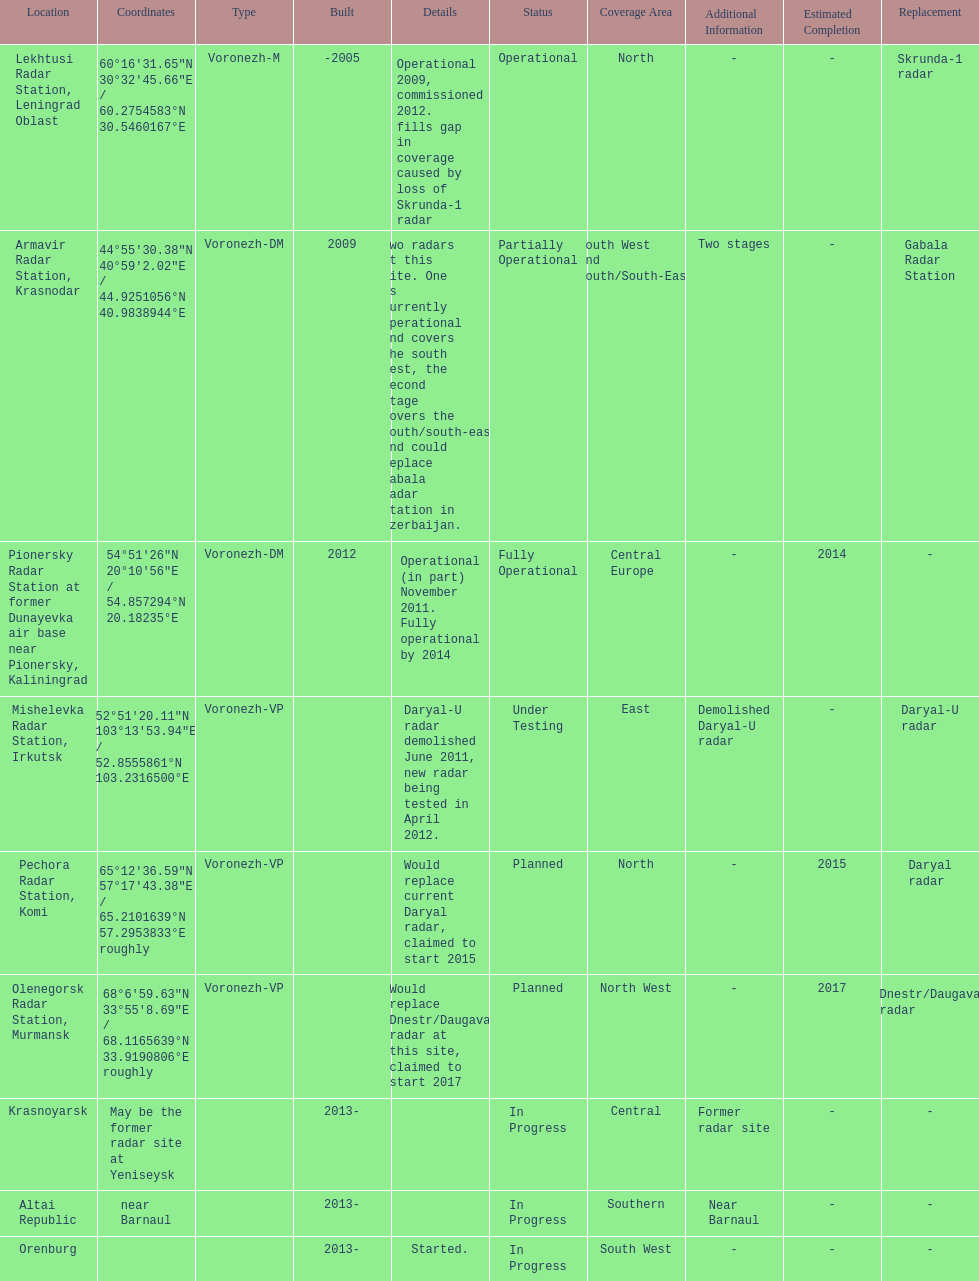How long did it take the pionersky radar station to go from partially operational to fully operational? 3 years. 